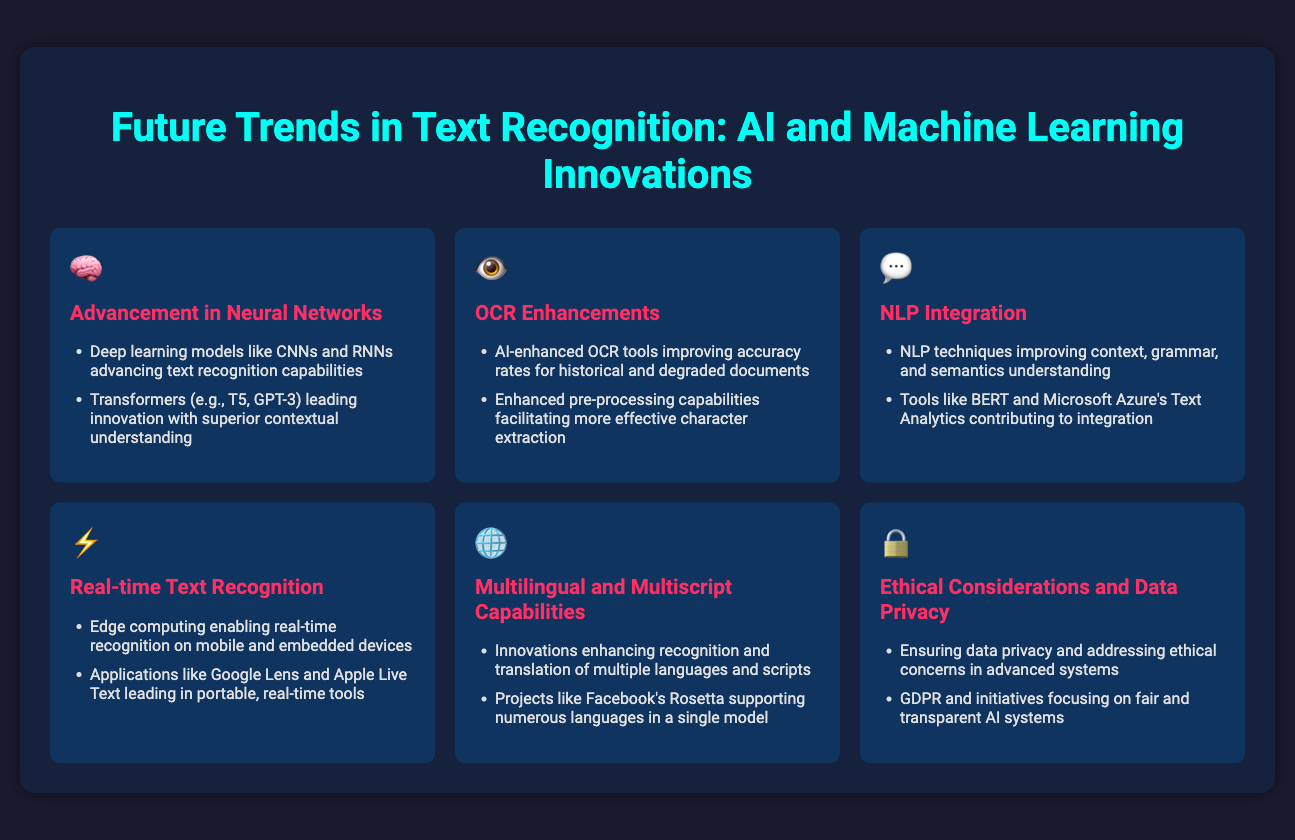What neural network models are advancing text recognition capabilities? The document mentions deep learning models like CNNs and RNNs advancing text recognition capabilities.
Answer: CNNs and RNNs What technology is leading innovation with superior contextual understanding? The document states that Transformers (e.g., T5, GPT-3) lead innovation with superior contextual understanding.
Answer: Transformers Which tools are enhancing OCR accuracy rates for historical documents? The document lists AI-enhanced OCR tools improving accuracy rates for historical and degraded documents.
Answer: AI-enhanced OCR tools What is enabling real-time recognition on mobile devices? According to the document, edge computing enables real-time recognition on mobile and embedded devices.
Answer: Edge computing What project supports numerous languages in a single model? The document mentions Facebook's Rosetta supporting numerous languages in a single model.
Answer: Facebook's Rosetta What are ethical considerations focused on in advanced text recognition systems? The document highlights ensuring data privacy and addressing ethical concerns in advanced systems as part of ethical considerations.
Answer: Data privacy How many benefits of NLP integration are mentioned in the document? The document mentions two benefits of NLP integration improving context, grammar, and semantics understanding.
Answer: Two Which applications are leading in portable, real-time text recognition tools? The document references applications like Google Lens and Apple Live Text leading in portable, real-time tools.
Answer: Google Lens and Apple Live Text Which GDPR-related issue is addressed in the document? The document discusses ensuring data privacy and addressing ethical concerns in advanced systems as related to GDPR.
Answer: Data privacy 